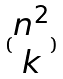<formula> <loc_0><loc_0><loc_500><loc_500>( \begin{matrix} n ^ { 2 } \\ k \end{matrix} )</formula> 